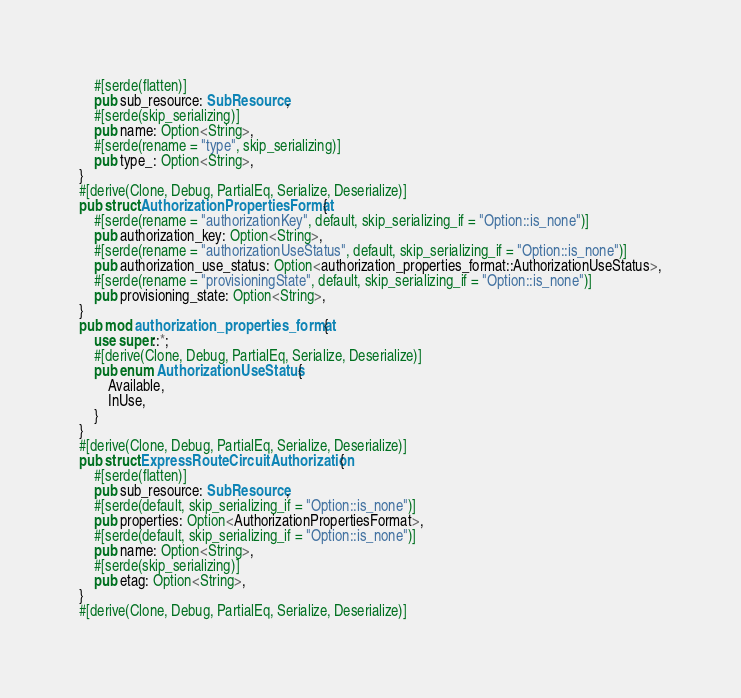<code> <loc_0><loc_0><loc_500><loc_500><_Rust_>    #[serde(flatten)]
    pub sub_resource: SubResource,
    #[serde(skip_serializing)]
    pub name: Option<String>,
    #[serde(rename = "type", skip_serializing)]
    pub type_: Option<String>,
}
#[derive(Clone, Debug, PartialEq, Serialize, Deserialize)]
pub struct AuthorizationPropertiesFormat {
    #[serde(rename = "authorizationKey", default, skip_serializing_if = "Option::is_none")]
    pub authorization_key: Option<String>,
    #[serde(rename = "authorizationUseStatus", default, skip_serializing_if = "Option::is_none")]
    pub authorization_use_status: Option<authorization_properties_format::AuthorizationUseStatus>,
    #[serde(rename = "provisioningState", default, skip_serializing_if = "Option::is_none")]
    pub provisioning_state: Option<String>,
}
pub mod authorization_properties_format {
    use super::*;
    #[derive(Clone, Debug, PartialEq, Serialize, Deserialize)]
    pub enum AuthorizationUseStatus {
        Available,
        InUse,
    }
}
#[derive(Clone, Debug, PartialEq, Serialize, Deserialize)]
pub struct ExpressRouteCircuitAuthorization {
    #[serde(flatten)]
    pub sub_resource: SubResource,
    #[serde(default, skip_serializing_if = "Option::is_none")]
    pub properties: Option<AuthorizationPropertiesFormat>,
    #[serde(default, skip_serializing_if = "Option::is_none")]
    pub name: Option<String>,
    #[serde(skip_serializing)]
    pub etag: Option<String>,
}
#[derive(Clone, Debug, PartialEq, Serialize, Deserialize)]</code> 